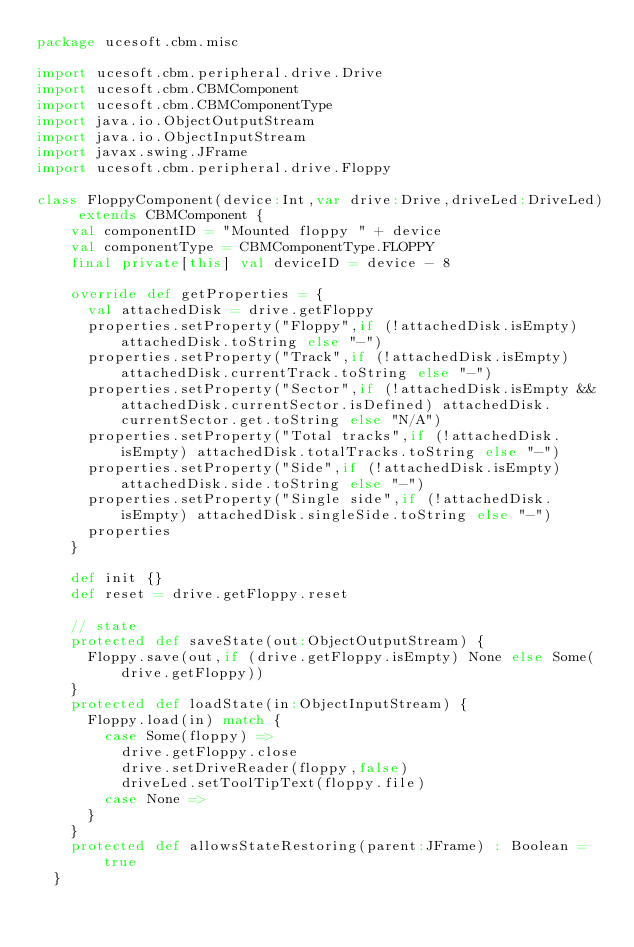Convert code to text. <code><loc_0><loc_0><loc_500><loc_500><_Scala_>package ucesoft.cbm.misc

import ucesoft.cbm.peripheral.drive.Drive
import ucesoft.cbm.CBMComponent
import ucesoft.cbm.CBMComponentType
import java.io.ObjectOutputStream
import java.io.ObjectInputStream
import javax.swing.JFrame
import ucesoft.cbm.peripheral.drive.Floppy

class FloppyComponent(device:Int,var drive:Drive,driveLed:DriveLed) extends CBMComponent {
    val componentID = "Mounted floppy " + device
    val componentType = CBMComponentType.FLOPPY
    final private[this] val deviceID = device - 8 
    
    override def getProperties = {
      val attachedDisk = drive.getFloppy      
      properties.setProperty("Floppy",if (!attachedDisk.isEmpty) attachedDisk.toString else "-")
      properties.setProperty("Track",if (!attachedDisk.isEmpty) attachedDisk.currentTrack.toString else "-")
      properties.setProperty("Sector",if (!attachedDisk.isEmpty && attachedDisk.currentSector.isDefined) attachedDisk.currentSector.get.toString else "N/A")
      properties.setProperty("Total tracks",if (!attachedDisk.isEmpty) attachedDisk.totalTracks.toString else "-")
      properties.setProperty("Side",if (!attachedDisk.isEmpty) attachedDisk.side.toString else "-")
      properties.setProperty("Single side",if (!attachedDisk.isEmpty) attachedDisk.singleSide.toString else "-")
      properties
    }
    
    def init {}
    def reset = drive.getFloppy.reset
    
    // state
    protected def saveState(out:ObjectOutputStream) {
      Floppy.save(out,if (drive.getFloppy.isEmpty) None else Some(drive.getFloppy))
    }
    protected def loadState(in:ObjectInputStream) {
      Floppy.load(in) match {
        case Some(floppy) =>
          drive.getFloppy.close
          drive.setDriveReader(floppy,false)
          driveLed.setToolTipText(floppy.file)
        case None =>
      }
    }
    protected def allowsStateRestoring(parent:JFrame) : Boolean = true
  }</code> 